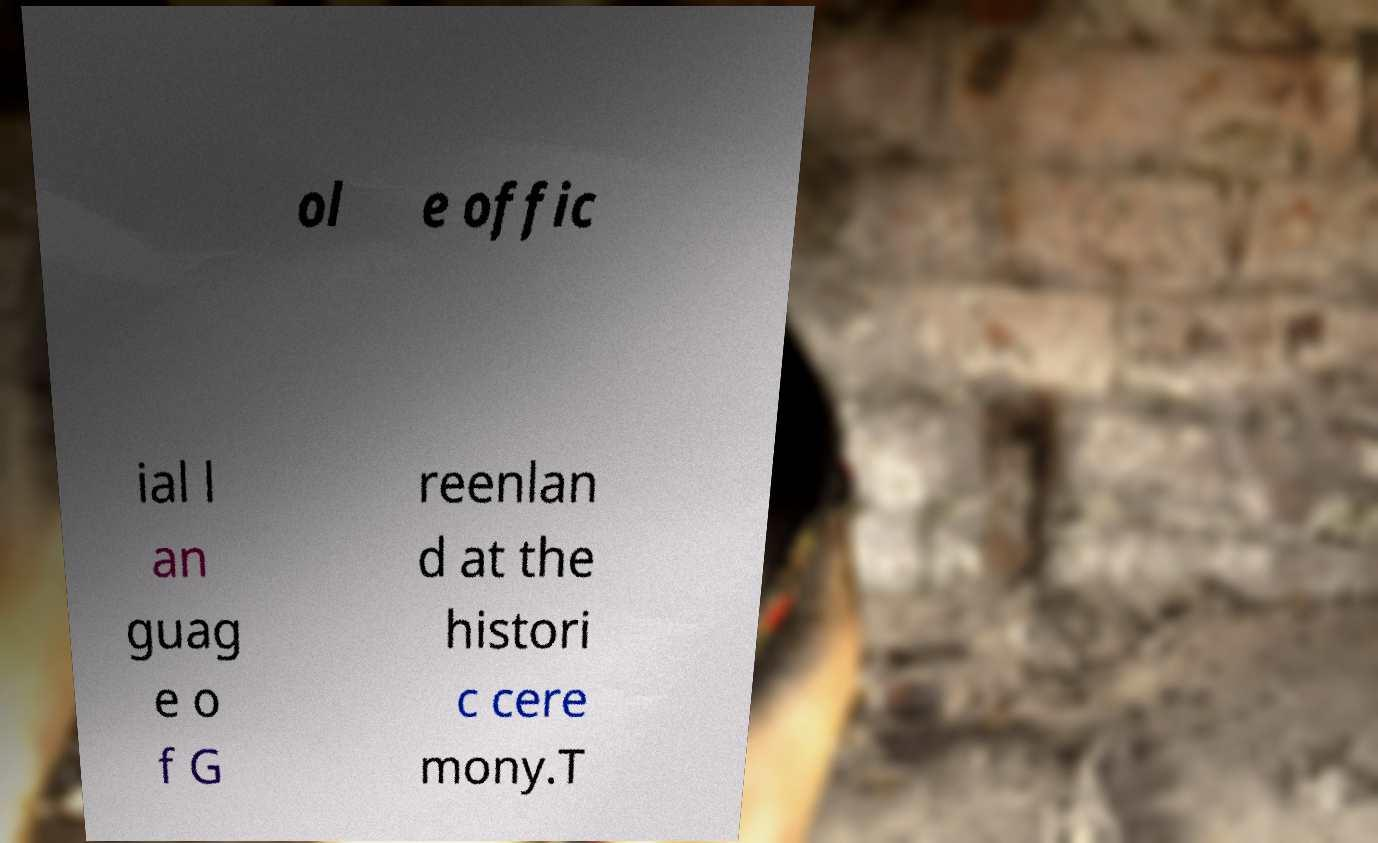What messages or text are displayed in this image? I need them in a readable, typed format. ol e offic ial l an guag e o f G reenlan d at the histori c cere mony.T 